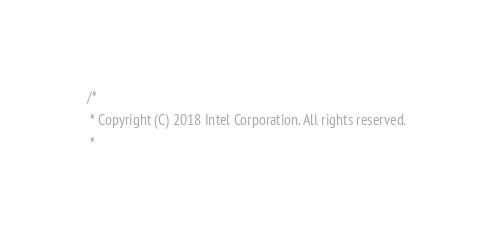Convert code to text. <code><loc_0><loc_0><loc_500><loc_500><_C_>/*
 * Copyright (C) 2018 Intel Corporation. All rights reserved.
 *</code> 